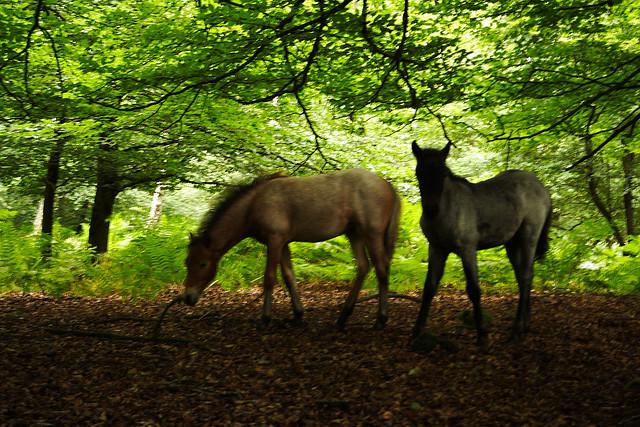Are these unicorns?
Quick response, please. No. What season does it appear to be?
Quick response, please. Summer. Is this picture on the beach?
Write a very short answer. No. 